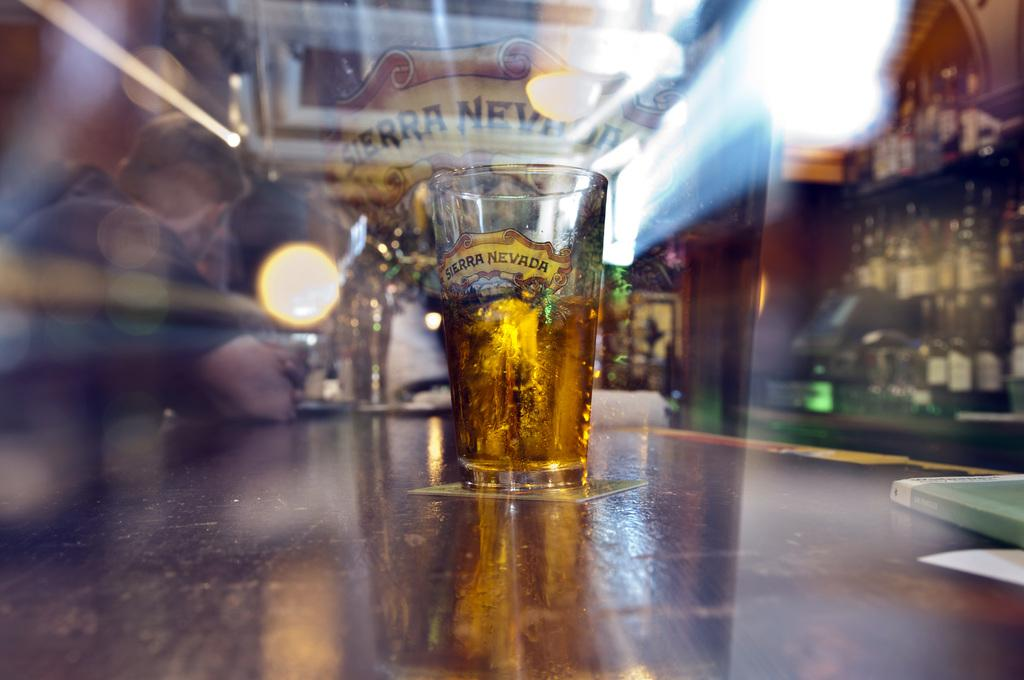<image>
Present a compact description of the photo's key features. the name Nevada is on the clear glass 